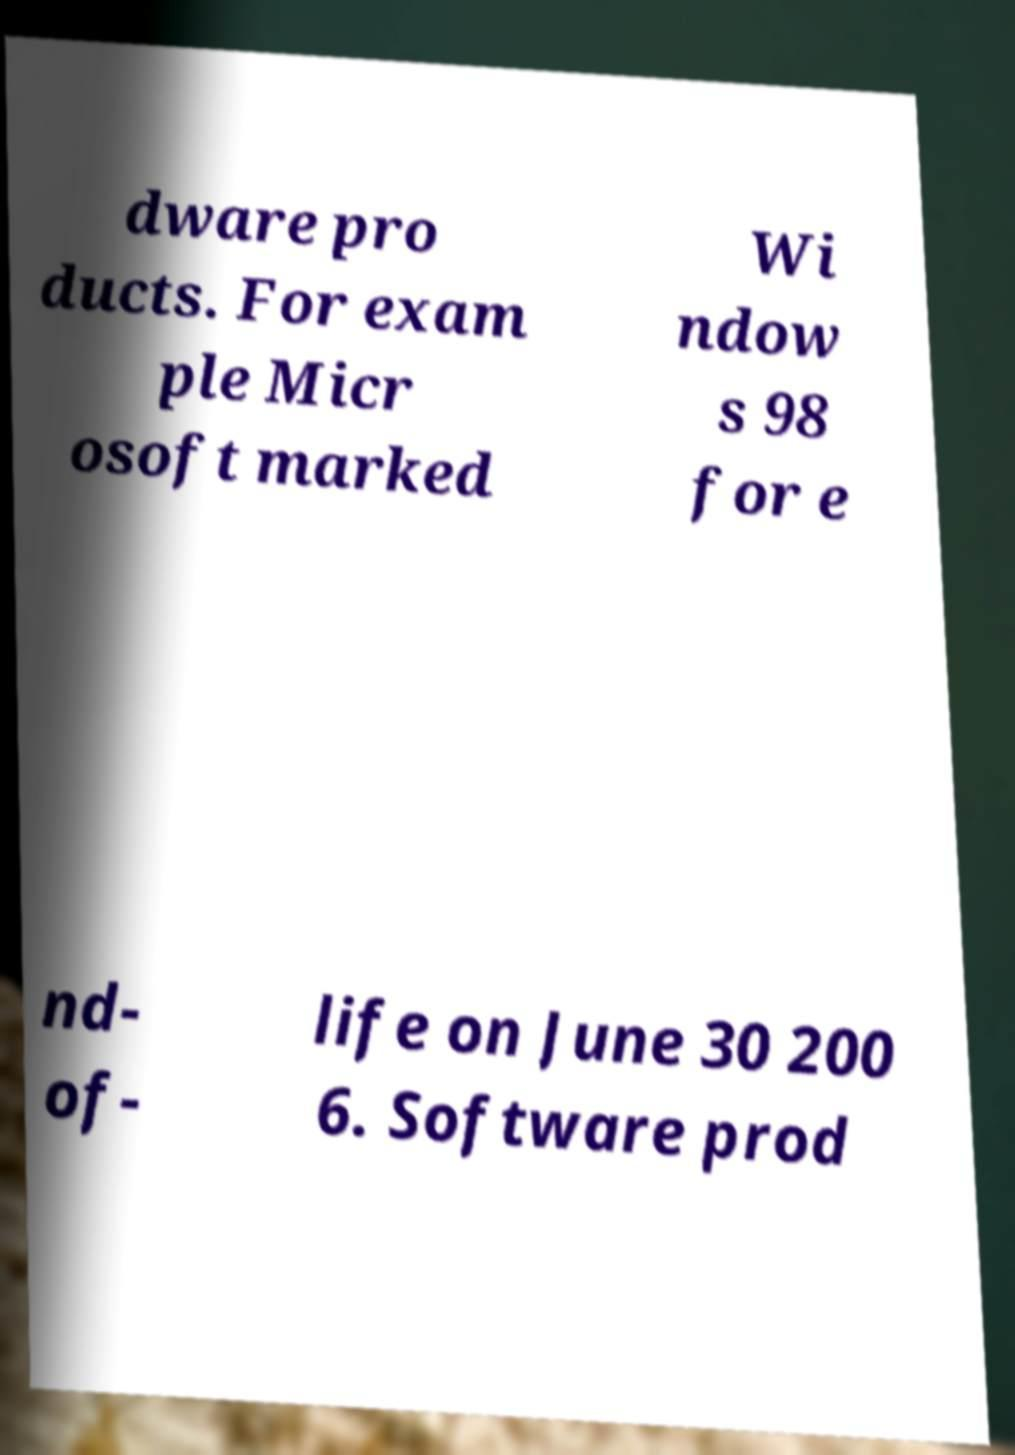Could you extract and type out the text from this image? dware pro ducts. For exam ple Micr osoft marked Wi ndow s 98 for e nd- of- life on June 30 200 6. Software prod 